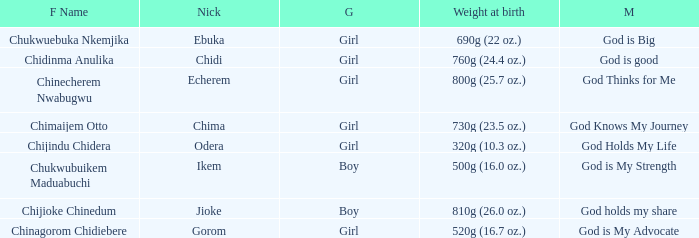How much did the girl, nicknamed Chidi, weigh at birth? 760g (24.4 oz.). 